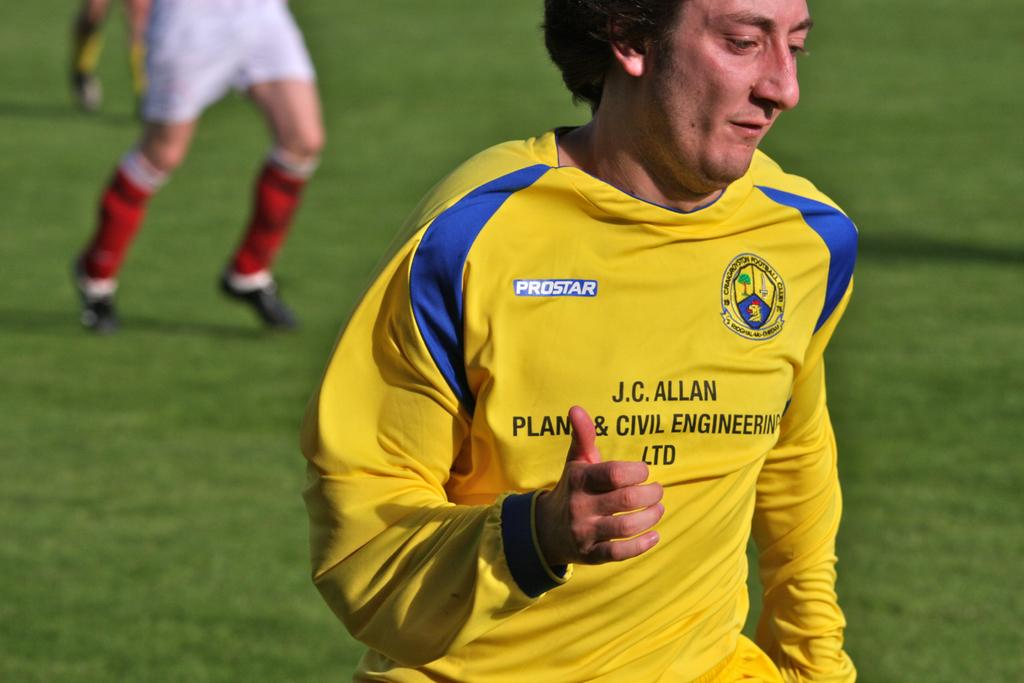<image>
Summarize the visual content of the image. A soccer player in a Prostar Yellow jersey. runs on the field. 